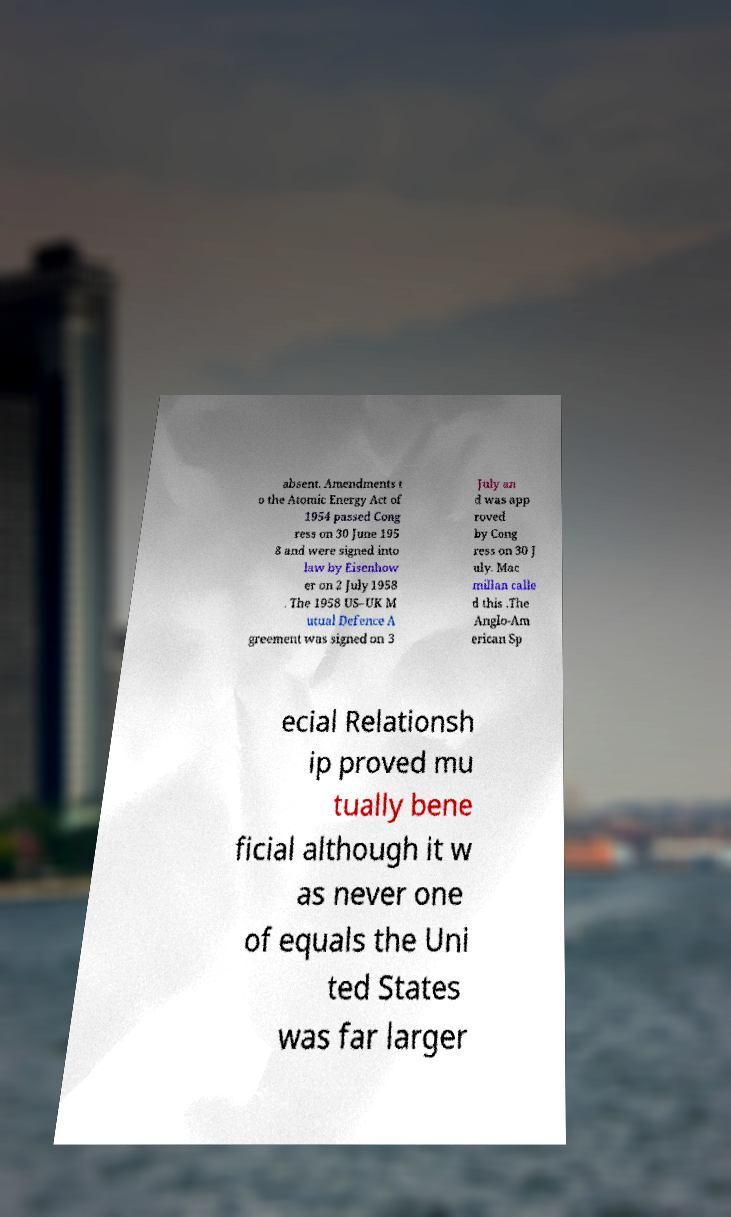Could you extract and type out the text from this image? absent. Amendments t o the Atomic Energy Act of 1954 passed Cong ress on 30 June 195 8 and were signed into law by Eisenhow er on 2 July 1958 . The 1958 US–UK M utual Defence A greement was signed on 3 July an d was app roved by Cong ress on 30 J uly. Mac millan calle d this .The Anglo-Am erican Sp ecial Relationsh ip proved mu tually bene ficial although it w as never one of equals the Uni ted States was far larger 